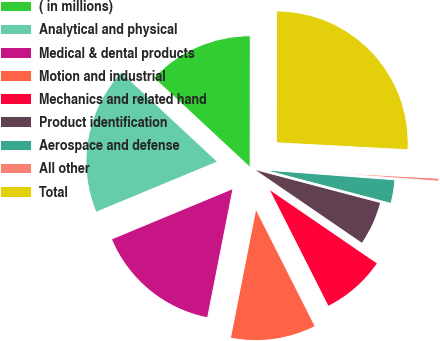<chart> <loc_0><loc_0><loc_500><loc_500><pie_chart><fcel>( in millions)<fcel>Analytical and physical<fcel>Medical & dental products<fcel>Motion and industrial<fcel>Mechanics and related hand<fcel>Product identification<fcel>Aerospace and defense<fcel>All other<fcel>Total<nl><fcel>13.09%<fcel>18.19%<fcel>15.64%<fcel>10.54%<fcel>8.0%<fcel>5.45%<fcel>2.9%<fcel>0.35%<fcel>25.83%<nl></chart> 